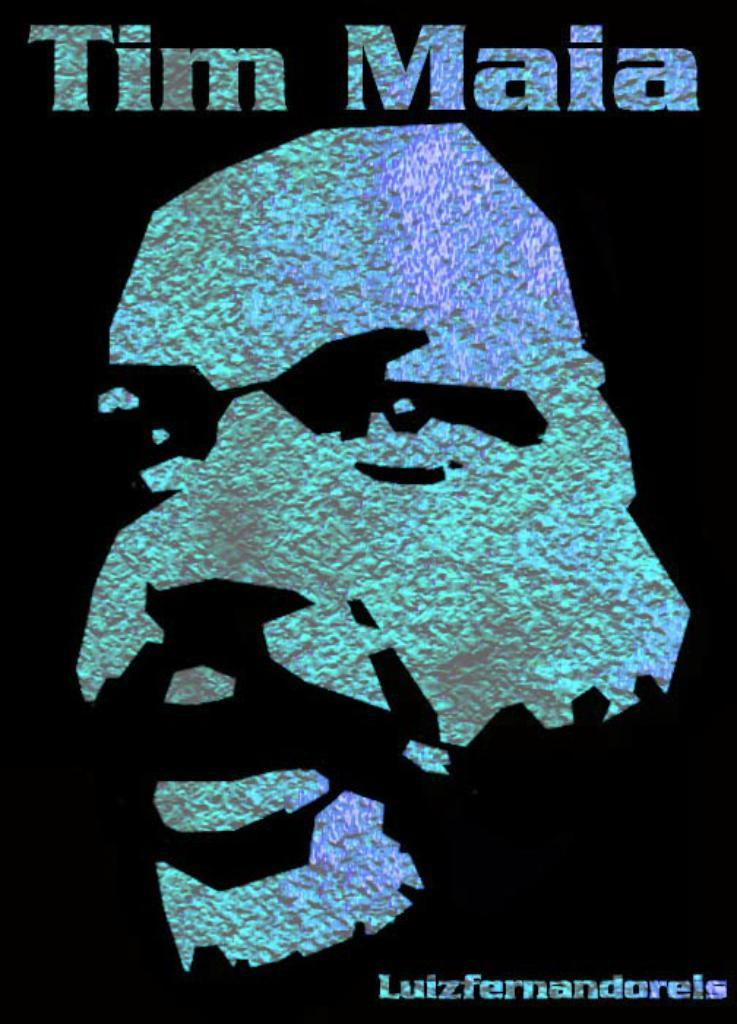<image>
Relay a brief, clear account of the picture shown. Poster showing a man's face and the name "Tim Maia". 